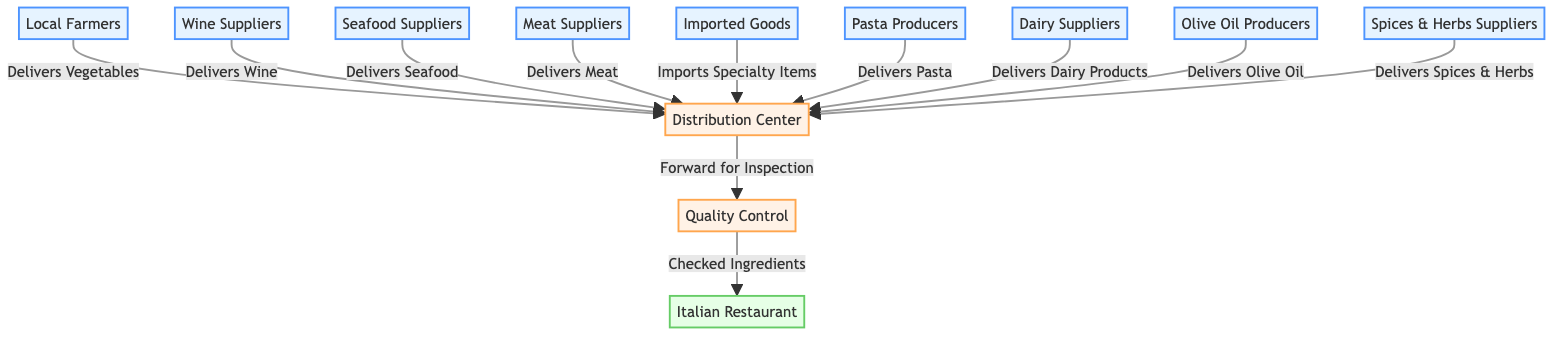What are the nodes in the network diagram? The nodes in the network are represented by suppliers such as Local Farmers, Wine Suppliers, Seafood Suppliers, Meat Suppliers, Imported Goods, Pasta Producers, Dairy Suppliers, Olive Oil Producers, Spices & Herbs Suppliers, a Distribution Center, Quality Control, and the Italian Restaurant itself.
Answer: Local Farmers, Wine Suppliers, Seafood Suppliers, Meat Suppliers, Imported Goods, Pasta Producers, Dairy Suppliers, Olive Oil Producers, Spices & Herbs Suppliers, Distribution Center, Quality Control, Italian Restaurant How many suppliers are there? To find the number of suppliers, we can count the nodes designated as suppliers, which include Local Farmers, Wine Suppliers, Seafood Suppliers, Meat Suppliers, Imported Goods, Pasta Producers, Dairy Suppliers, Olive Oil Producers, and Spices & Herbs Suppliers, totaling nine.
Answer: 9 Which supplier delivers dairy products? Referring to the diagram, the Dairy Suppliers node is the one that specifically delivers dairy products to the Distribution Center.
Answer: Dairy Suppliers What is the function of the Quality Control node? The Quality Control node is linked to the Distribution Center, receiving ingredients for inspection after they have been delivered. Its function is to ensure that only checked ingredients are forwarded to the restaurant.
Answer: Forward for Inspection Which supplier imports specialty items? The Imported Goods supplier is identified as the one responsible for importing specialty items to the Distribution Center, as indicated in the diagram.
Answer: Imported Goods How many edges are connected to the Distribution Center? Counting the edges connected to the Distribution Center, we observe that it has a total of ten edges linked to it, representing the deliveries from various suppliers.
Answer: 10 Which nodes are connected to the restaurant node? The restaurant node is connected to the Quality Control node, meaning it receives the checked ingredients from Quality Control as part of the supply chain.
Answer: Quality Control What is the first step in the supply chain process? The first step in the supply chain process involves the suppliers delivering goods to the Distribution Center, where they are then forwarded for inspection.
Answer: Delivers to Distribution Center Name one type of product delivered by seafood suppliers. Referring to the edge leading from the Seafood Suppliers to the Distribution Center, it is clear that seafood is the type of product delivered by this supplier.
Answer: Seafood 